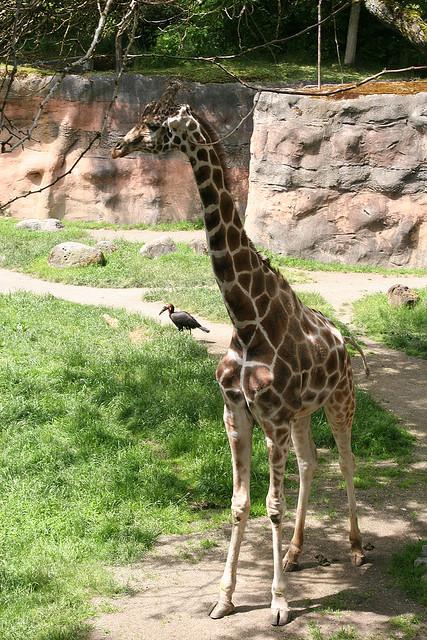Can you see birds?
Be succinct. Yes. Is there shade?
Be succinct. Yes. How many animals are in this photo?
Give a very brief answer. 2. 